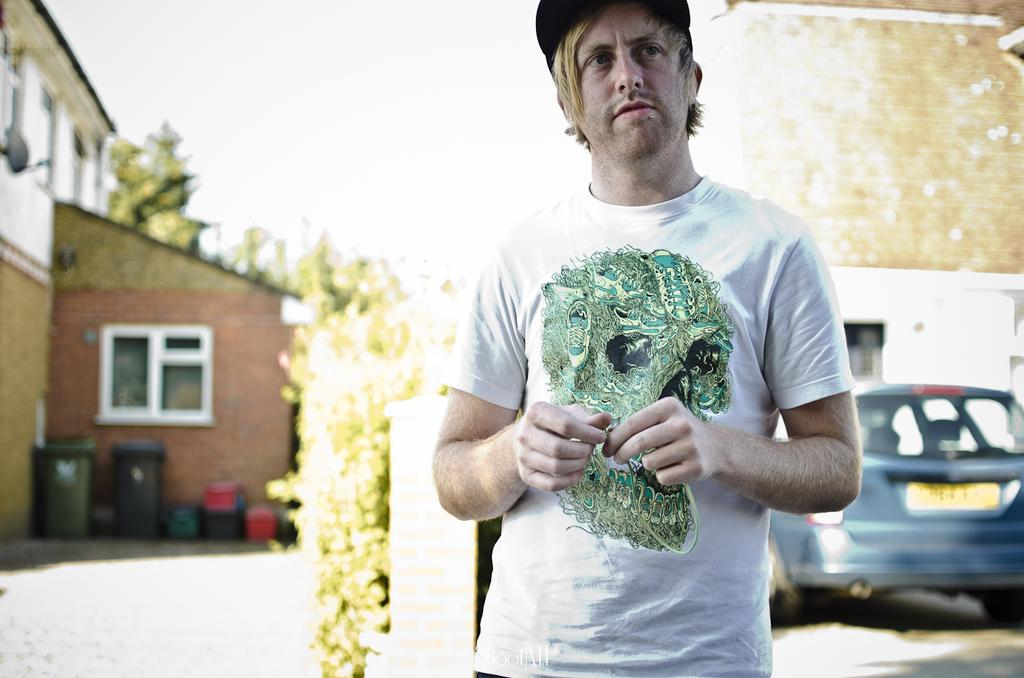What is present in the image? There is a person and a vehicle on the ground in the image. What can be seen in the background of the image? There are buildings and the sky visible in the background of the image. Can you describe the unspecified objects in the background? Unfortunately, the provided facts do not specify the nature of these objects, so we cannot describe them. What is the minister doing in the image? There is no minister present in the image. What things are being discussed by the nation in the image? There is no reference to a nation or any discussion in the image. 